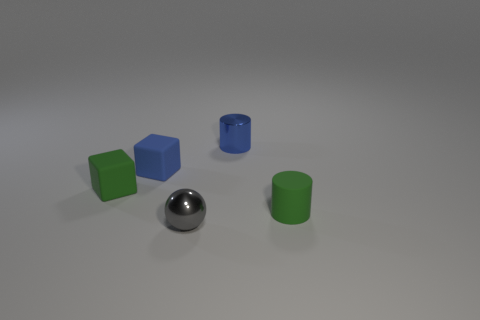Add 4 gray metal cubes. How many objects exist? 9 Subtract all cubes. How many objects are left? 3 Subtract 0 blue balls. How many objects are left? 5 Subtract 1 cylinders. How many cylinders are left? 1 Subtract all gray cylinders. Subtract all brown cubes. How many cylinders are left? 2 Subtract all green balls. How many gray cubes are left? 0 Subtract all green matte objects. Subtract all large red metal cylinders. How many objects are left? 3 Add 5 tiny rubber cylinders. How many tiny rubber cylinders are left? 6 Add 5 cylinders. How many cylinders exist? 7 